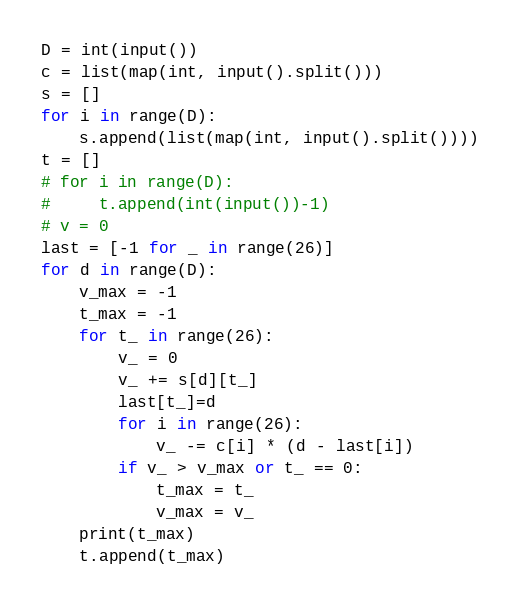<code> <loc_0><loc_0><loc_500><loc_500><_Python_>D = int(input())
c = list(map(int, input().split()))
s = []
for i in range(D):
    s.append(list(map(int, input().split())))
t = []
# for i in range(D):
#     t.append(int(input())-1)
# v = 0 
last = [-1 for _ in range(26)]
for d in range(D):
    v_max = -1
    t_max = -1
    for t_ in range(26):
        v_ = 0
        v_ += s[d][t_]
        last[t_]=d
        for i in range(26):
            v_ -= c[i] * (d - last[i])
        if v_ > v_max or t_ == 0:
            t_max = t_
            v_max = v_
    print(t_max)
    t.append(t_max)</code> 